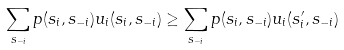<formula> <loc_0><loc_0><loc_500><loc_500>\sum _ { s _ { - i } } p ( s _ { i } , s _ { - i } ) u _ { i } ( s _ { i } , s _ { - i } ) \geq \sum _ { s _ { - i } } p ( s _ { i } , s _ { - i } ) u _ { i } ( s _ { i } ^ { \prime } , s _ { - i } )</formula> 